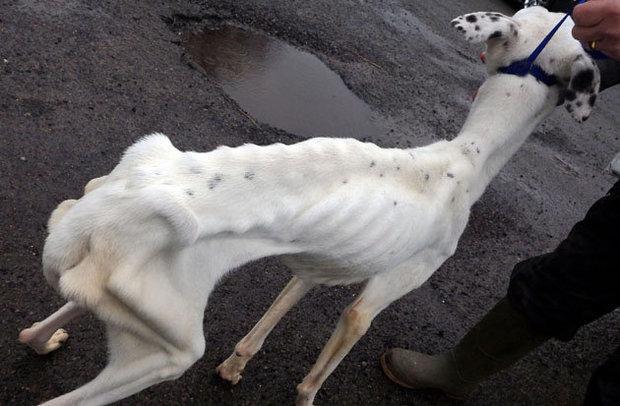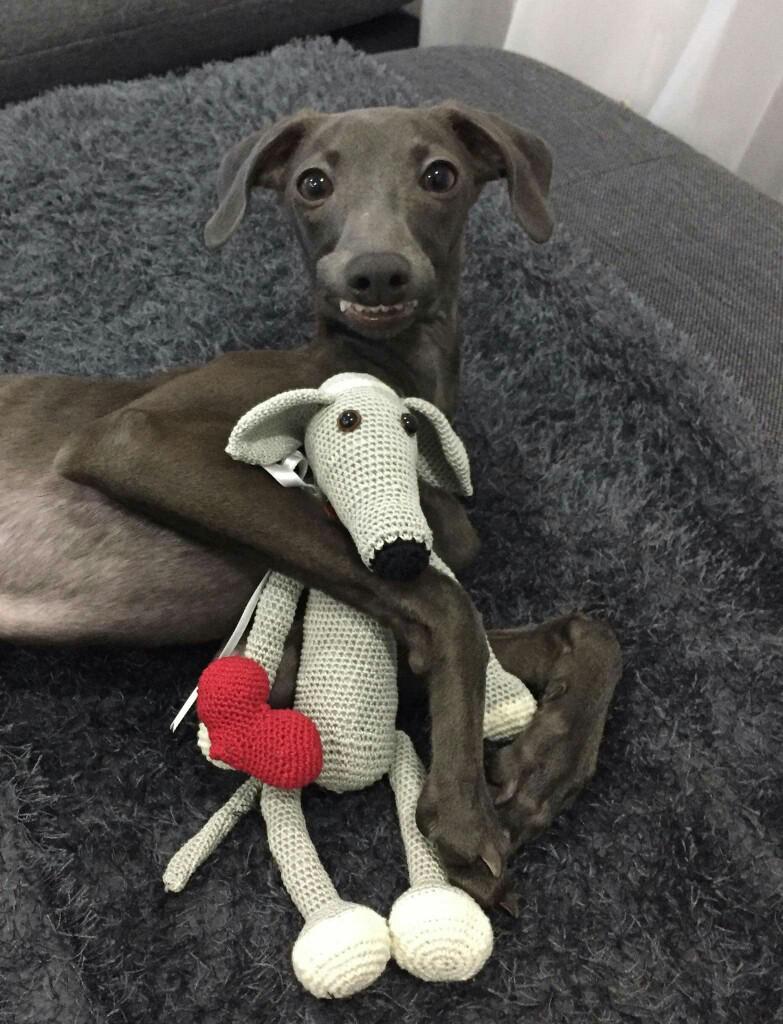The first image is the image on the left, the second image is the image on the right. Assess this claim about the two images: "A dog in one image is cradling a stuffed animal toy while lying on a furry dark gray throw.". Correct or not? Answer yes or no. Yes. The first image is the image on the left, the second image is the image on the right. Examine the images to the left and right. Is the description "An image shows a hound hugging a stuffed animal." accurate? Answer yes or no. Yes. 